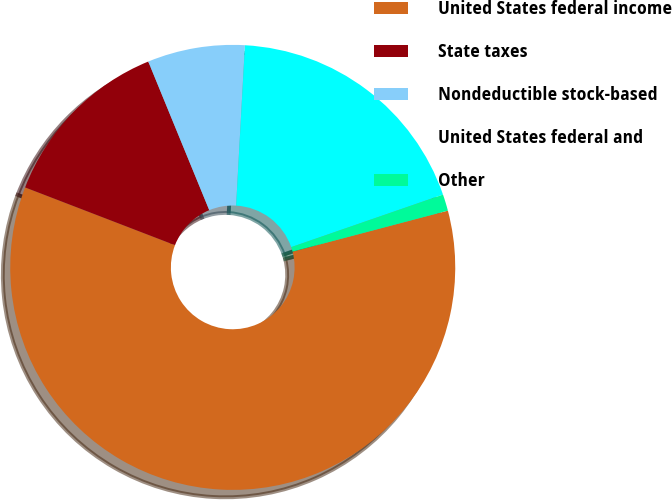<chart> <loc_0><loc_0><loc_500><loc_500><pie_chart><fcel>United States federal income<fcel>State taxes<fcel>Nondeductible stock-based<fcel>United States federal and<fcel>Other<nl><fcel>59.95%<fcel>12.95%<fcel>7.07%<fcel>18.82%<fcel>1.2%<nl></chart> 